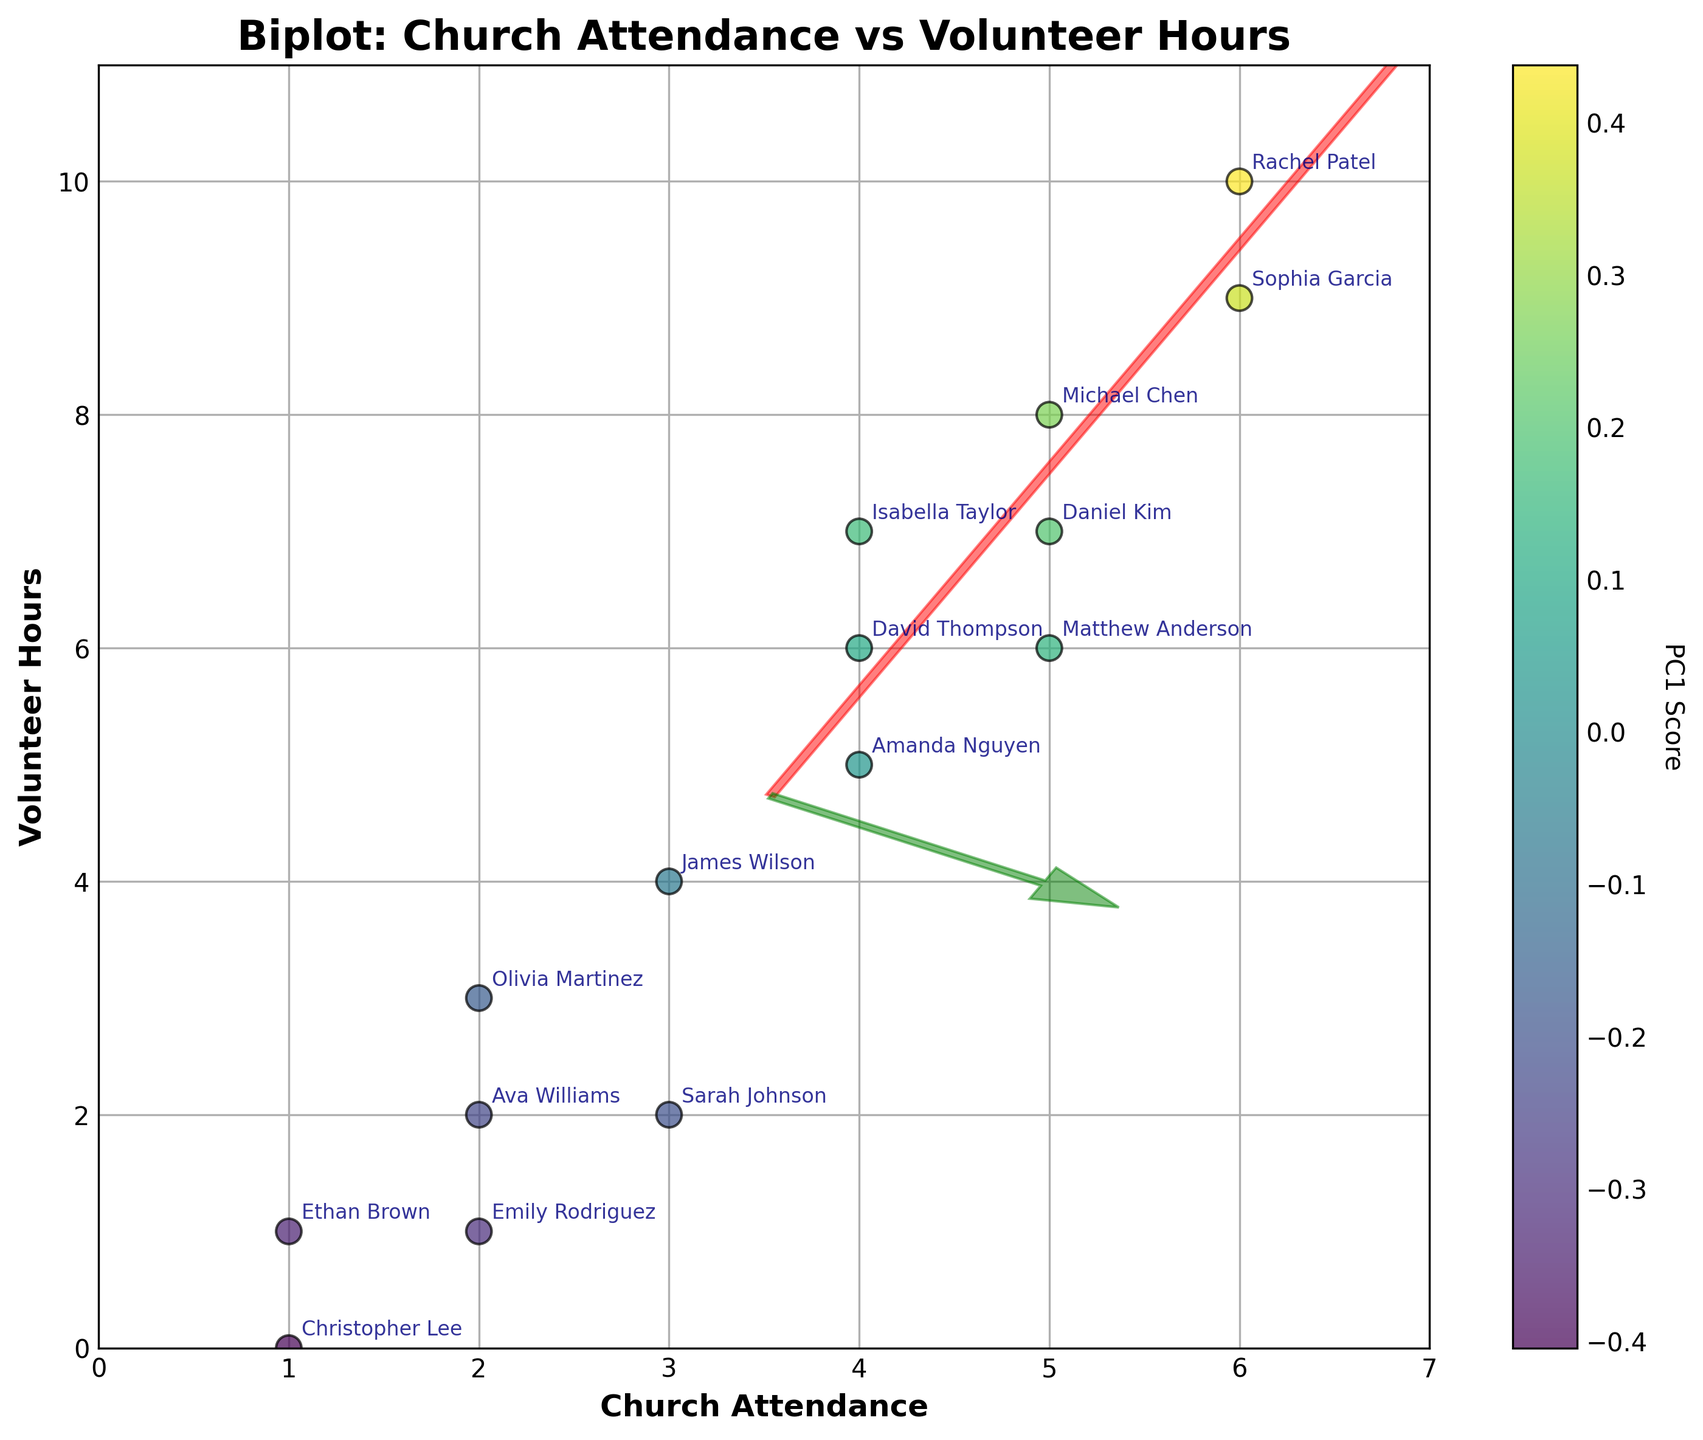How many members have a church attendance value of 6? There are two data points where the x-value (Church Attendance) is 6. They correspond to Rachel Patel and Sophia Garcia.
Answer: 2 Which member has the highest number of volunteer hours? By looking at the y-axis values, the highest value is 10, which corresponds to Rachel Patel.
Answer: Rachel Patel What is the average number of volunteer hours for members who attend church 3 times? There are two members who attend church 3 times: Sarah Johnson with 2 volunteer hours and James Wilson with 4 volunteer hours. The average is (2 + 4) / 2 = 3.
Answer: 3 How are the eigenvectors represented in the plot, and what do their colors signify? The eigenvectors are represented as arrows in the plot, with the first principal component (PC1) in red and the second principal component (PC2) in green.
Answer: Arrows; Red and Green Compare the church attendance and volunteer hours of Michael Chen and Daniel Kim. Michael Chen attends church 5 times and has 8 volunteer hours. Daniel Kim also attends church 5 times but has 7 volunteer hours. Therefore, Michael has 1 more volunteer hour than Daniel.
Answer: Michael Chen has 1 more volunteer hour What does the color of each data point indicate? The color of each data point indicates the score on the first principal component (PC1). The color scheme follows a 'viridis' colormap.
Answer: PC1 score Which two members have the lowest and highest PC1 score based on the color gradient? The member with the darkest color (indicating the lowest PC1 score) is Christopher Lee, and the member with the lightest color (indicating the highest PC1 score) is Rachel Patel.
Answer: Christopher Lee and Rachel Patel What is the total number of volunteer hours combined for all members who attend church 2 times? Members with 2 times attendance are Emily Rodriguez, Olivia Martinez, and Ava Williams, with 1, 3, and 2 volunteer hours respectively. Total hours = 1 + 3 + 2 = 6.
Answer: 6 What general correlation can you observe between church attendance and volunteer hours? There is a positive correlation; as church attendance increases, the number of volunteer hours also generally increases.
Answer: Positive correlation 